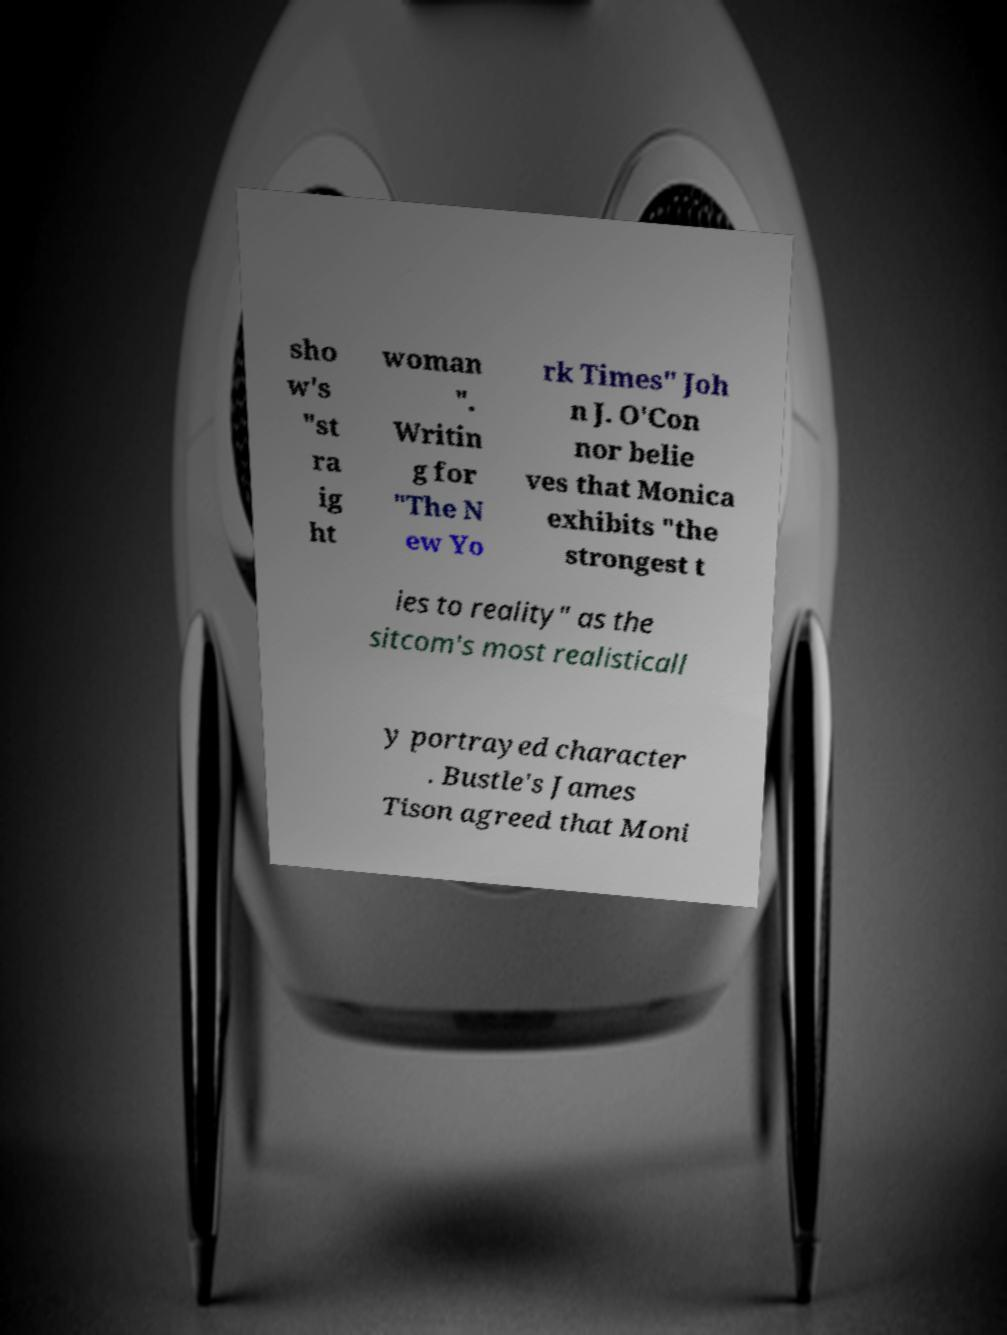There's text embedded in this image that I need extracted. Can you transcribe it verbatim? sho w's "st ra ig ht woman ". Writin g for "The N ew Yo rk Times" Joh n J. O'Con nor belie ves that Monica exhibits "the strongest t ies to reality" as the sitcom's most realisticall y portrayed character . Bustle's James Tison agreed that Moni 